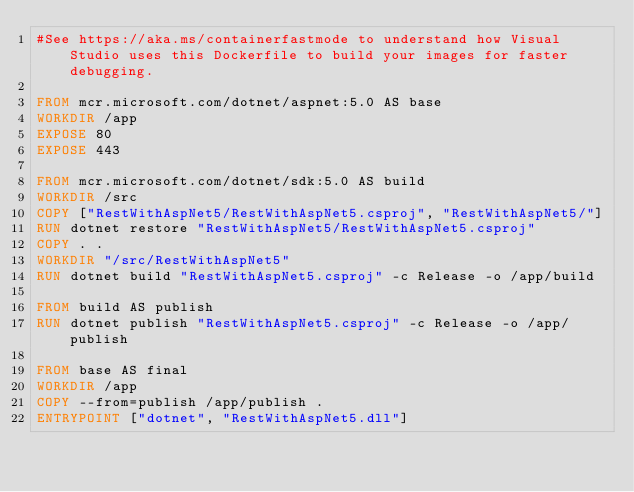Convert code to text. <code><loc_0><loc_0><loc_500><loc_500><_Dockerfile_>#See https://aka.ms/containerfastmode to understand how Visual Studio uses this Dockerfile to build your images for faster debugging.

FROM mcr.microsoft.com/dotnet/aspnet:5.0 AS base
WORKDIR /app
EXPOSE 80
EXPOSE 443

FROM mcr.microsoft.com/dotnet/sdk:5.0 AS build
WORKDIR /src
COPY ["RestWithAspNet5/RestWithAspNet5.csproj", "RestWithAspNet5/"]
RUN dotnet restore "RestWithAspNet5/RestWithAspNet5.csproj"
COPY . .
WORKDIR "/src/RestWithAspNet5"
RUN dotnet build "RestWithAspNet5.csproj" -c Release -o /app/build

FROM build AS publish
RUN dotnet publish "RestWithAspNet5.csproj" -c Release -o /app/publish

FROM base AS final
WORKDIR /app
COPY --from=publish /app/publish .
ENTRYPOINT ["dotnet", "RestWithAspNet5.dll"]
</code> 